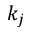Convert formula to latex. <formula><loc_0><loc_0><loc_500><loc_500>k _ { j }</formula> 